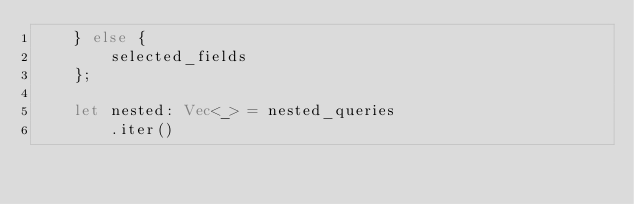<code> <loc_0><loc_0><loc_500><loc_500><_Rust_>    } else {
        selected_fields
    };

    let nested: Vec<_> = nested_queries
        .iter()</code> 